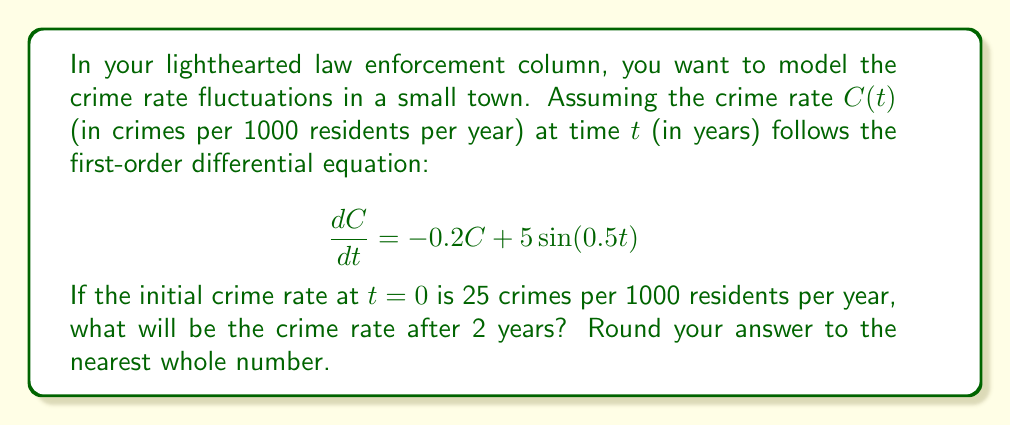Provide a solution to this math problem. To solve this first-order linear differential equation, we'll use the integrating factor method:

1) The equation is in the form $\frac{dC}{dt} + 0.2C = 5\sin(0.5t)$

2) The integrating factor is $\mu(t) = e^{\int 0.2 dt} = e^{0.2t}$

3) Multiply both sides of the equation by $\mu(t)$:

   $e^{0.2t}\frac{dC}{dt} + 0.2Ce^{0.2t} = 5e^{0.2t}\sin(0.5t)$

4) The left side is now the derivative of $Ce^{0.2t}$:

   $\frac{d}{dt}(Ce^{0.2t}) = 5e^{0.2t}\sin(0.5t)$

5) Integrate both sides:

   $Ce^{0.2t} = 5\int e^{0.2t}\sin(0.5t)dt$

6) The integral on the right side can be solved using integration by parts. The result is:

   $Ce^{0.2t} = 5(\frac{0.2\sin(0.5t) - 0.5\cos(0.5t)}{0.04 + 0.25})e^{0.2t} + K$

7) Solve for $C$:

   $C = 5(\frac{0.2\sin(0.5t) - 0.5\cos(0.5t)}{0.29}) + Ke^{-0.2t}$

8) Use the initial condition $C(0) = 25$ to find $K$:

   $25 = 5(-\frac{0.5}{0.29}) + K$
   $K = 25 + \frac{5(0.5)}{0.29} \approx 33.62$

9) The final solution is:

   $C(t) = 5(\frac{0.2\sin(0.5t) - 0.5\cos(0.5t)}{0.29}) + 33.62e^{-0.2t}$

10) Evaluate at $t=2$:

    $C(2) = 5(\frac{0.2\sin(1) - 0.5\cos(1)}{0.29}) + 33.62e^{-0.4} \approx 22.76$

11) Rounding to the nearest whole number: 23
Answer: 23 crimes per 1000 residents per year 